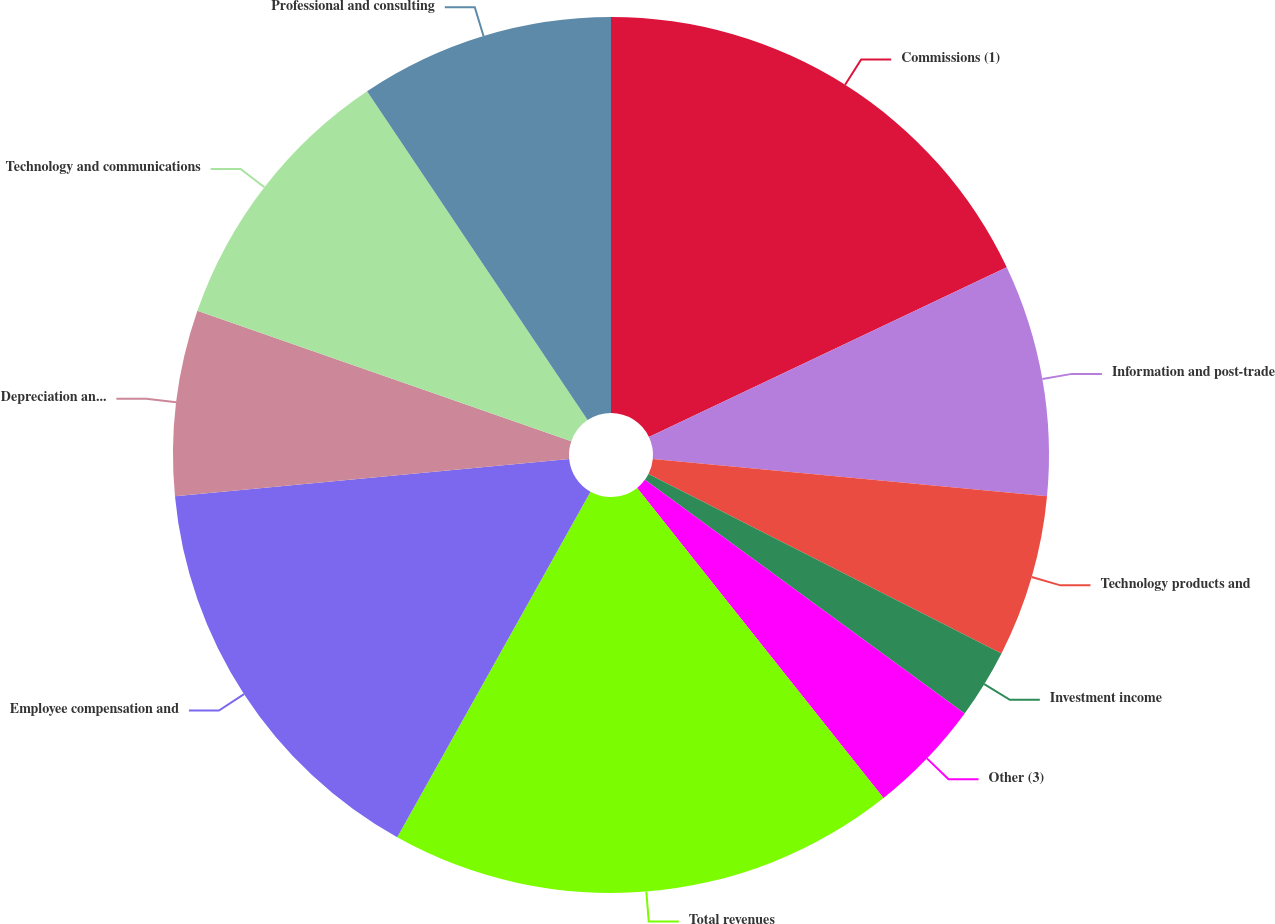Convert chart. <chart><loc_0><loc_0><loc_500><loc_500><pie_chart><fcel>Commissions (1)<fcel>Information and post-trade<fcel>Technology products and<fcel>Investment income<fcel>Other (3)<fcel>Total revenues<fcel>Employee compensation and<fcel>Depreciation and amortization<fcel>Technology and communications<fcel>Professional and consulting<nl><fcel>17.95%<fcel>8.55%<fcel>5.98%<fcel>2.56%<fcel>4.27%<fcel>18.8%<fcel>15.38%<fcel>6.84%<fcel>10.26%<fcel>9.4%<nl></chart> 